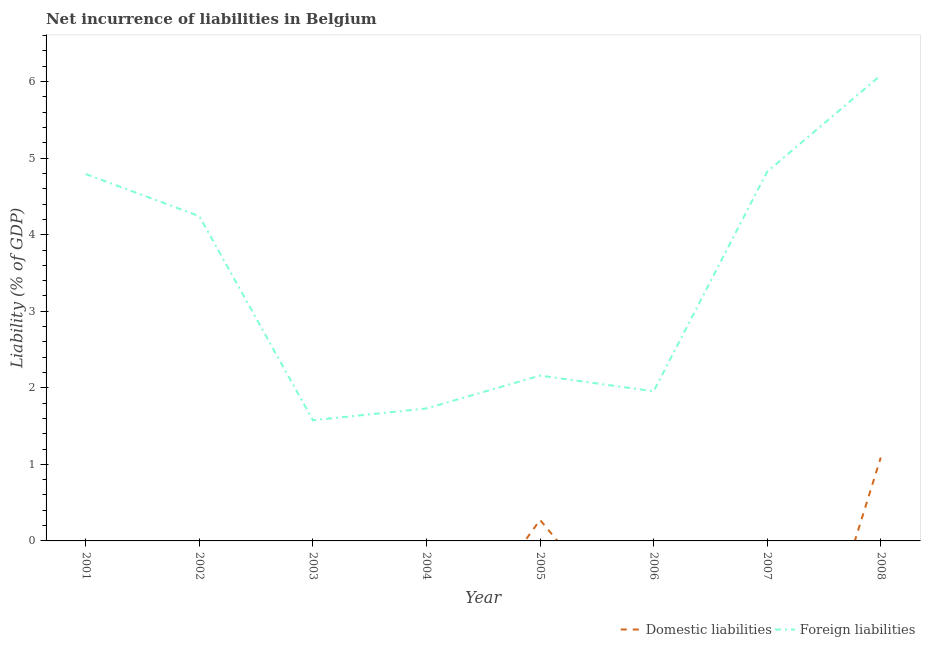How many different coloured lines are there?
Make the answer very short. 2. Does the line corresponding to incurrence of domestic liabilities intersect with the line corresponding to incurrence of foreign liabilities?
Make the answer very short. No. What is the incurrence of foreign liabilities in 2003?
Your answer should be compact. 1.58. Across all years, what is the maximum incurrence of domestic liabilities?
Provide a short and direct response. 1.09. Across all years, what is the minimum incurrence of foreign liabilities?
Provide a succinct answer. 1.58. In which year was the incurrence of foreign liabilities maximum?
Provide a short and direct response. 2008. What is the total incurrence of foreign liabilities in the graph?
Keep it short and to the point. 27.36. What is the difference between the incurrence of domestic liabilities in 2005 and that in 2008?
Keep it short and to the point. -0.81. What is the difference between the incurrence of foreign liabilities in 2003 and the incurrence of domestic liabilities in 2007?
Give a very brief answer. 1.58. What is the average incurrence of foreign liabilities per year?
Provide a succinct answer. 3.42. In the year 2008, what is the difference between the incurrence of foreign liabilities and incurrence of domestic liabilities?
Offer a terse response. 4.99. In how many years, is the incurrence of foreign liabilities greater than 3.8 %?
Your response must be concise. 4. What is the ratio of the incurrence of foreign liabilities in 2007 to that in 2008?
Ensure brevity in your answer.  0.79. Is the incurrence of foreign liabilities in 2001 less than that in 2002?
Your answer should be very brief. No. What is the difference between the highest and the second highest incurrence of foreign liabilities?
Your answer should be very brief. 1.26. What is the difference between the highest and the lowest incurrence of foreign liabilities?
Give a very brief answer. 4.51. Is the incurrence of foreign liabilities strictly greater than the incurrence of domestic liabilities over the years?
Offer a terse response. Yes. Is the incurrence of domestic liabilities strictly less than the incurrence of foreign liabilities over the years?
Provide a succinct answer. Yes. Are the values on the major ticks of Y-axis written in scientific E-notation?
Offer a terse response. No. Does the graph contain any zero values?
Your answer should be compact. Yes. Does the graph contain grids?
Ensure brevity in your answer.  No. How many legend labels are there?
Your answer should be very brief. 2. What is the title of the graph?
Offer a very short reply. Net incurrence of liabilities in Belgium. What is the label or title of the X-axis?
Offer a very short reply. Year. What is the label or title of the Y-axis?
Your answer should be very brief. Liability (% of GDP). What is the Liability (% of GDP) of Domestic liabilities in 2001?
Make the answer very short. 0. What is the Liability (% of GDP) of Foreign liabilities in 2001?
Give a very brief answer. 4.79. What is the Liability (% of GDP) in Domestic liabilities in 2002?
Offer a very short reply. 0. What is the Liability (% of GDP) in Foreign liabilities in 2002?
Provide a succinct answer. 4.24. What is the Liability (% of GDP) of Foreign liabilities in 2003?
Offer a very short reply. 1.58. What is the Liability (% of GDP) in Domestic liabilities in 2004?
Keep it short and to the point. 0. What is the Liability (% of GDP) of Foreign liabilities in 2004?
Ensure brevity in your answer.  1.73. What is the Liability (% of GDP) of Domestic liabilities in 2005?
Provide a succinct answer. 0.27. What is the Liability (% of GDP) in Foreign liabilities in 2005?
Make the answer very short. 2.16. What is the Liability (% of GDP) of Foreign liabilities in 2006?
Make the answer very short. 1.95. What is the Liability (% of GDP) in Foreign liabilities in 2007?
Your answer should be very brief. 4.82. What is the Liability (% of GDP) of Domestic liabilities in 2008?
Your answer should be compact. 1.09. What is the Liability (% of GDP) of Foreign liabilities in 2008?
Give a very brief answer. 6.08. Across all years, what is the maximum Liability (% of GDP) in Domestic liabilities?
Give a very brief answer. 1.09. Across all years, what is the maximum Liability (% of GDP) of Foreign liabilities?
Your answer should be compact. 6.08. Across all years, what is the minimum Liability (% of GDP) in Foreign liabilities?
Offer a very short reply. 1.58. What is the total Liability (% of GDP) of Domestic liabilities in the graph?
Give a very brief answer. 1.36. What is the total Liability (% of GDP) in Foreign liabilities in the graph?
Offer a very short reply. 27.36. What is the difference between the Liability (% of GDP) of Foreign liabilities in 2001 and that in 2002?
Ensure brevity in your answer.  0.55. What is the difference between the Liability (% of GDP) of Foreign liabilities in 2001 and that in 2003?
Ensure brevity in your answer.  3.22. What is the difference between the Liability (% of GDP) in Foreign liabilities in 2001 and that in 2004?
Your response must be concise. 3.06. What is the difference between the Liability (% of GDP) in Foreign liabilities in 2001 and that in 2005?
Offer a terse response. 2.63. What is the difference between the Liability (% of GDP) of Foreign liabilities in 2001 and that in 2006?
Give a very brief answer. 2.84. What is the difference between the Liability (% of GDP) of Foreign liabilities in 2001 and that in 2007?
Keep it short and to the point. -0.03. What is the difference between the Liability (% of GDP) of Foreign liabilities in 2001 and that in 2008?
Your answer should be very brief. -1.29. What is the difference between the Liability (% of GDP) in Foreign liabilities in 2002 and that in 2003?
Keep it short and to the point. 2.67. What is the difference between the Liability (% of GDP) of Foreign liabilities in 2002 and that in 2004?
Ensure brevity in your answer.  2.51. What is the difference between the Liability (% of GDP) of Foreign liabilities in 2002 and that in 2005?
Provide a succinct answer. 2.08. What is the difference between the Liability (% of GDP) of Foreign liabilities in 2002 and that in 2006?
Offer a very short reply. 2.29. What is the difference between the Liability (% of GDP) in Foreign liabilities in 2002 and that in 2007?
Offer a very short reply. -0.58. What is the difference between the Liability (% of GDP) in Foreign liabilities in 2002 and that in 2008?
Your answer should be compact. -1.84. What is the difference between the Liability (% of GDP) of Foreign liabilities in 2003 and that in 2004?
Provide a short and direct response. -0.15. What is the difference between the Liability (% of GDP) of Foreign liabilities in 2003 and that in 2005?
Offer a terse response. -0.58. What is the difference between the Liability (% of GDP) of Foreign liabilities in 2003 and that in 2006?
Provide a succinct answer. -0.38. What is the difference between the Liability (% of GDP) of Foreign liabilities in 2003 and that in 2007?
Offer a very short reply. -3.25. What is the difference between the Liability (% of GDP) of Foreign liabilities in 2003 and that in 2008?
Offer a very short reply. -4.51. What is the difference between the Liability (% of GDP) in Foreign liabilities in 2004 and that in 2005?
Make the answer very short. -0.43. What is the difference between the Liability (% of GDP) of Foreign liabilities in 2004 and that in 2006?
Your answer should be very brief. -0.22. What is the difference between the Liability (% of GDP) of Foreign liabilities in 2004 and that in 2007?
Offer a terse response. -3.09. What is the difference between the Liability (% of GDP) of Foreign liabilities in 2004 and that in 2008?
Your response must be concise. -4.35. What is the difference between the Liability (% of GDP) in Foreign liabilities in 2005 and that in 2006?
Provide a succinct answer. 0.21. What is the difference between the Liability (% of GDP) of Foreign liabilities in 2005 and that in 2007?
Your answer should be very brief. -2.66. What is the difference between the Liability (% of GDP) in Domestic liabilities in 2005 and that in 2008?
Make the answer very short. -0.81. What is the difference between the Liability (% of GDP) of Foreign liabilities in 2005 and that in 2008?
Provide a succinct answer. -3.92. What is the difference between the Liability (% of GDP) of Foreign liabilities in 2006 and that in 2007?
Offer a very short reply. -2.87. What is the difference between the Liability (% of GDP) in Foreign liabilities in 2006 and that in 2008?
Provide a succinct answer. -4.13. What is the difference between the Liability (% of GDP) in Foreign liabilities in 2007 and that in 2008?
Make the answer very short. -1.26. What is the difference between the Liability (% of GDP) in Domestic liabilities in 2005 and the Liability (% of GDP) in Foreign liabilities in 2006?
Provide a short and direct response. -1.68. What is the difference between the Liability (% of GDP) of Domestic liabilities in 2005 and the Liability (% of GDP) of Foreign liabilities in 2007?
Offer a very short reply. -4.55. What is the difference between the Liability (% of GDP) in Domestic liabilities in 2005 and the Liability (% of GDP) in Foreign liabilities in 2008?
Your answer should be compact. -5.81. What is the average Liability (% of GDP) in Domestic liabilities per year?
Offer a very short reply. 0.17. What is the average Liability (% of GDP) in Foreign liabilities per year?
Ensure brevity in your answer.  3.42. In the year 2005, what is the difference between the Liability (% of GDP) in Domestic liabilities and Liability (% of GDP) in Foreign liabilities?
Give a very brief answer. -1.89. In the year 2008, what is the difference between the Liability (% of GDP) in Domestic liabilities and Liability (% of GDP) in Foreign liabilities?
Provide a succinct answer. -4.99. What is the ratio of the Liability (% of GDP) of Foreign liabilities in 2001 to that in 2002?
Provide a short and direct response. 1.13. What is the ratio of the Liability (% of GDP) of Foreign liabilities in 2001 to that in 2003?
Offer a terse response. 3.04. What is the ratio of the Liability (% of GDP) of Foreign liabilities in 2001 to that in 2004?
Offer a very short reply. 2.77. What is the ratio of the Liability (% of GDP) of Foreign liabilities in 2001 to that in 2005?
Ensure brevity in your answer.  2.22. What is the ratio of the Liability (% of GDP) in Foreign liabilities in 2001 to that in 2006?
Ensure brevity in your answer.  2.45. What is the ratio of the Liability (% of GDP) in Foreign liabilities in 2001 to that in 2008?
Offer a very short reply. 0.79. What is the ratio of the Liability (% of GDP) of Foreign liabilities in 2002 to that in 2003?
Provide a short and direct response. 2.69. What is the ratio of the Liability (% of GDP) of Foreign liabilities in 2002 to that in 2004?
Provide a short and direct response. 2.45. What is the ratio of the Liability (% of GDP) of Foreign liabilities in 2002 to that in 2005?
Provide a succinct answer. 1.96. What is the ratio of the Liability (% of GDP) in Foreign liabilities in 2002 to that in 2006?
Your answer should be compact. 2.17. What is the ratio of the Liability (% of GDP) in Foreign liabilities in 2002 to that in 2007?
Offer a terse response. 0.88. What is the ratio of the Liability (% of GDP) of Foreign liabilities in 2002 to that in 2008?
Keep it short and to the point. 0.7. What is the ratio of the Liability (% of GDP) in Foreign liabilities in 2003 to that in 2004?
Your answer should be very brief. 0.91. What is the ratio of the Liability (% of GDP) of Foreign liabilities in 2003 to that in 2005?
Your response must be concise. 0.73. What is the ratio of the Liability (% of GDP) of Foreign liabilities in 2003 to that in 2006?
Your response must be concise. 0.81. What is the ratio of the Liability (% of GDP) in Foreign liabilities in 2003 to that in 2007?
Offer a terse response. 0.33. What is the ratio of the Liability (% of GDP) in Foreign liabilities in 2003 to that in 2008?
Provide a short and direct response. 0.26. What is the ratio of the Liability (% of GDP) in Foreign liabilities in 2004 to that in 2005?
Offer a terse response. 0.8. What is the ratio of the Liability (% of GDP) of Foreign liabilities in 2004 to that in 2006?
Ensure brevity in your answer.  0.89. What is the ratio of the Liability (% of GDP) of Foreign liabilities in 2004 to that in 2007?
Keep it short and to the point. 0.36. What is the ratio of the Liability (% of GDP) in Foreign liabilities in 2004 to that in 2008?
Offer a very short reply. 0.28. What is the ratio of the Liability (% of GDP) of Foreign liabilities in 2005 to that in 2006?
Keep it short and to the point. 1.11. What is the ratio of the Liability (% of GDP) in Foreign liabilities in 2005 to that in 2007?
Provide a short and direct response. 0.45. What is the ratio of the Liability (% of GDP) of Domestic liabilities in 2005 to that in 2008?
Ensure brevity in your answer.  0.25. What is the ratio of the Liability (% of GDP) of Foreign liabilities in 2005 to that in 2008?
Make the answer very short. 0.36. What is the ratio of the Liability (% of GDP) of Foreign liabilities in 2006 to that in 2007?
Keep it short and to the point. 0.41. What is the ratio of the Liability (% of GDP) in Foreign liabilities in 2006 to that in 2008?
Your answer should be compact. 0.32. What is the ratio of the Liability (% of GDP) of Foreign liabilities in 2007 to that in 2008?
Your answer should be compact. 0.79. What is the difference between the highest and the second highest Liability (% of GDP) of Foreign liabilities?
Provide a succinct answer. 1.26. What is the difference between the highest and the lowest Liability (% of GDP) in Domestic liabilities?
Make the answer very short. 1.09. What is the difference between the highest and the lowest Liability (% of GDP) of Foreign liabilities?
Your answer should be very brief. 4.51. 